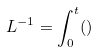<formula> <loc_0><loc_0><loc_500><loc_500>L ^ { - 1 } = \int _ { 0 } ^ { t } ( )</formula> 